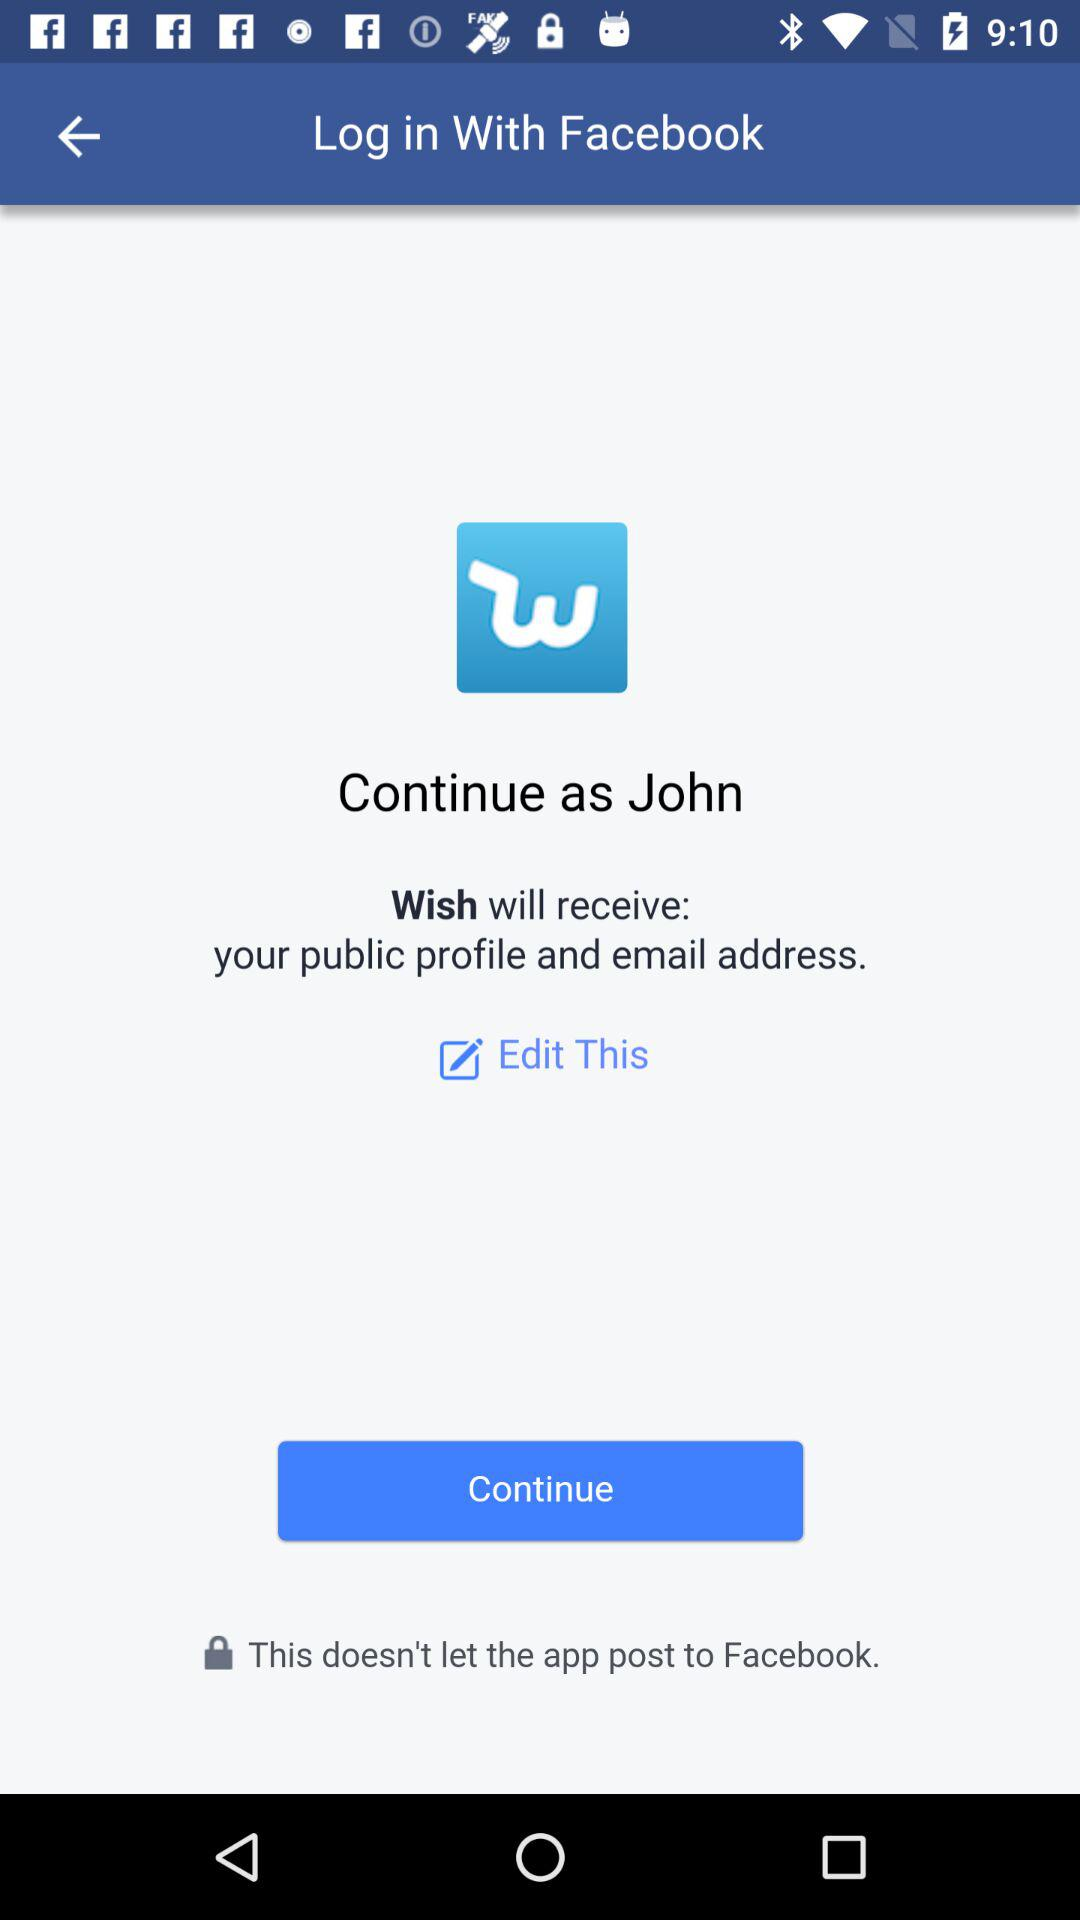What application will receive my public profile and email address? The application "Wish" will receive your public profile and email address. 